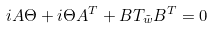Convert formula to latex. <formula><loc_0><loc_0><loc_500><loc_500>i A \Theta + i \Theta A ^ { T } + B T _ { \tilde { w } } B ^ { T } = 0</formula> 